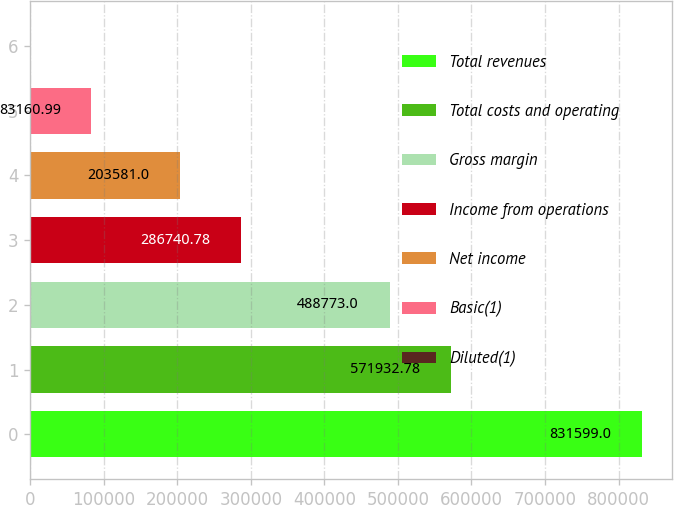<chart> <loc_0><loc_0><loc_500><loc_500><bar_chart><fcel>Total revenues<fcel>Total costs and operating<fcel>Gross margin<fcel>Income from operations<fcel>Net income<fcel>Basic(1)<fcel>Diluted(1)<nl><fcel>831599<fcel>571933<fcel>488773<fcel>286741<fcel>203581<fcel>83161<fcel>1.21<nl></chart> 